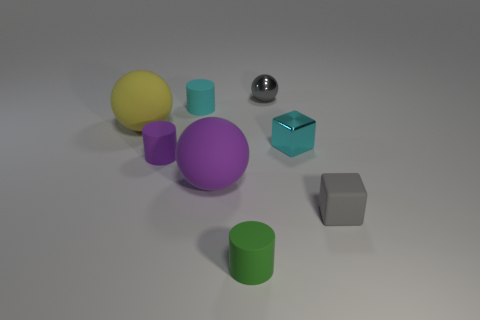Are there any small green matte cubes?
Offer a very short reply. No. There is another purple object that is the same material as the small purple object; what size is it?
Make the answer very short. Large. Are there any tiny objects that have the same color as the metal ball?
Your answer should be compact. Yes. There is a tiny matte cylinder behind the small cyan shiny cube; does it have the same color as the small metal object that is in front of the cyan rubber cylinder?
Keep it short and to the point. Yes. Are there any big gray objects made of the same material as the green object?
Make the answer very short. No. What color is the rubber block?
Provide a succinct answer. Gray. There is a yellow sphere behind the small block that is right of the small cube that is behind the matte block; what size is it?
Offer a terse response. Large. How many other things are the same shape as the gray matte thing?
Offer a terse response. 1. There is a tiny thing that is both in front of the tiny gray ball and behind the tiny cyan metallic object; what is its color?
Your answer should be very brief. Cyan. There is a rubber cube that is on the right side of the green thing; is it the same color as the small sphere?
Your answer should be compact. Yes. 